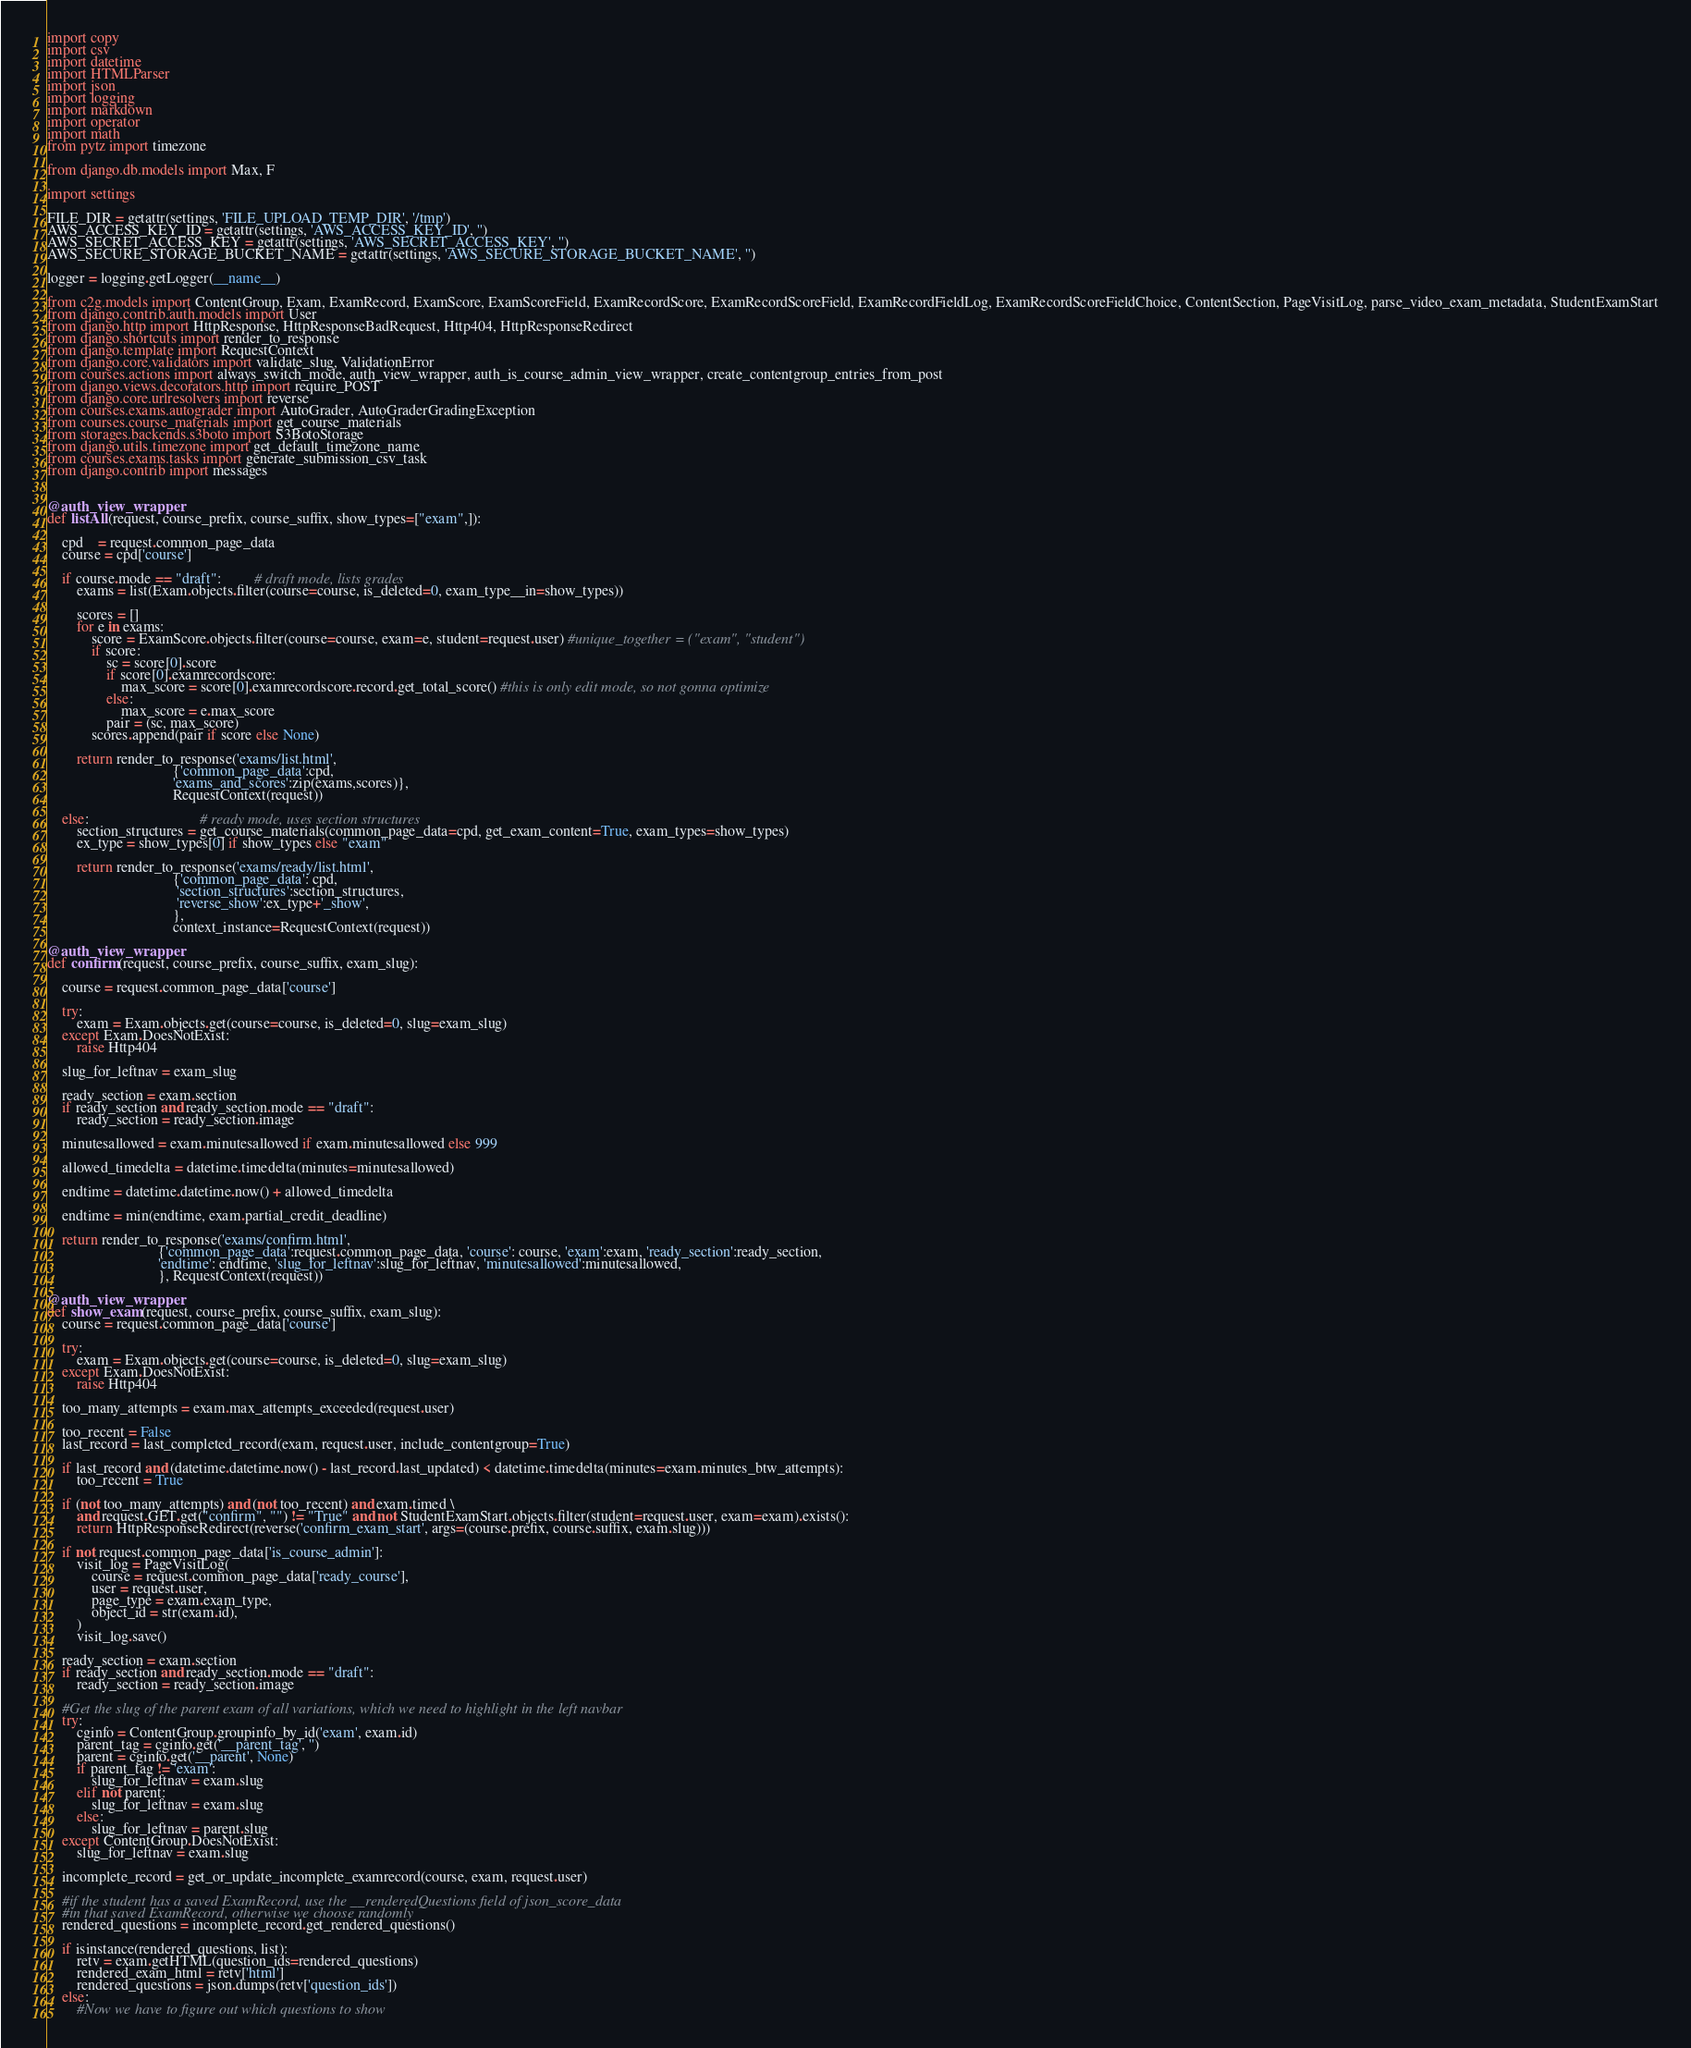<code> <loc_0><loc_0><loc_500><loc_500><_Python_>import copy
import csv
import datetime
import HTMLParser
import json
import logging
import markdown
import operator
import math
from pytz import timezone

from django.db.models import Max, F

import settings

FILE_DIR = getattr(settings, 'FILE_UPLOAD_TEMP_DIR', '/tmp')
AWS_ACCESS_KEY_ID = getattr(settings, 'AWS_ACCESS_KEY_ID', '')
AWS_SECRET_ACCESS_KEY = getattr(settings, 'AWS_SECRET_ACCESS_KEY', '')
AWS_SECURE_STORAGE_BUCKET_NAME = getattr(settings, 'AWS_SECURE_STORAGE_BUCKET_NAME', '')

logger = logging.getLogger(__name__)

from c2g.models import ContentGroup, Exam, ExamRecord, ExamScore, ExamScoreField, ExamRecordScore, ExamRecordScoreField, ExamRecordFieldLog, ExamRecordScoreFieldChoice, ContentSection, PageVisitLog, parse_video_exam_metadata, StudentExamStart
from django.contrib.auth.models import User
from django.http import HttpResponse, HttpResponseBadRequest, Http404, HttpResponseRedirect
from django.shortcuts import render_to_response
from django.template import RequestContext
from django.core.validators import validate_slug, ValidationError
from courses.actions import always_switch_mode, auth_view_wrapper, auth_is_course_admin_view_wrapper, create_contentgroup_entries_from_post
from django.views.decorators.http import require_POST
from django.core.urlresolvers import reverse
from courses.exams.autograder import AutoGrader, AutoGraderGradingException 
from courses.course_materials import get_course_materials
from storages.backends.s3boto import S3BotoStorage
from django.utils.timezone import get_default_timezone_name
from courses.exams.tasks import generate_submission_csv_task
from django.contrib import messages


@auth_view_wrapper
def listAll(request, course_prefix, course_suffix, show_types=["exam",]):
    
    cpd    = request.common_page_data
    course = cpd['course']

    if course.mode == "draft":         # draft mode, lists grades
        exams = list(Exam.objects.filter(course=course, is_deleted=0, exam_type__in=show_types))

        scores = []
        for e in exams:
            score = ExamScore.objects.filter(course=course, exam=e, student=request.user) #unique_together = ("exam", "student")
            if score:
                sc = score[0].score
                if score[0].examrecordscore:
                    max_score = score[0].examrecordscore.record.get_total_score() #this is only edit mode, so not gonna optimize
                else:
                    max_score = e.max_score
                pair = (sc, max_score)
            scores.append(pair if score else None)

        return render_to_response('exams/list.html',
                                  {'common_page_data':cpd,
                                  'exams_and_scores':zip(exams,scores)},
                                  RequestContext(request))

    else:                              # ready mode, uses section structures
        section_structures = get_course_materials(common_page_data=cpd, get_exam_content=True, exam_types=show_types)
        ex_type = show_types[0] if show_types else "exam" 
        
        return render_to_response('exams/ready/list.html', 
                                  {'common_page_data': cpd, 
                                   'section_structures':section_structures, 
                                   'reverse_show':ex_type+'_show', 
                                  }, 
                                  context_instance=RequestContext(request))

@auth_view_wrapper
def confirm(request, course_prefix, course_suffix, exam_slug):
    
    course = request.common_page_data['course']
        
    try:
        exam = Exam.objects.get(course=course, is_deleted=0, slug=exam_slug)
    except Exam.DoesNotExist:
        raise Http404

    slug_for_leftnav = exam_slug

    ready_section = exam.section
    if ready_section and ready_section.mode == "draft":
        ready_section = ready_section.image

    minutesallowed = exam.minutesallowed if exam.minutesallowed else 999

    allowed_timedelta = datetime.timedelta(minutes=minutesallowed)

    endtime = datetime.datetime.now() + allowed_timedelta
    
    endtime = min(endtime, exam.partial_credit_deadline)

    return render_to_response('exams/confirm.html',
                              {'common_page_data':request.common_page_data, 'course': course, 'exam':exam, 'ready_section':ready_section,
                              'endtime': endtime, 'slug_for_leftnav':slug_for_leftnav, 'minutesallowed':minutesallowed,
                              }, RequestContext(request))

@auth_view_wrapper
def show_exam(request, course_prefix, course_suffix, exam_slug):
    course = request.common_page_data['course']
    
    try:
        exam = Exam.objects.get(course=course, is_deleted=0, slug=exam_slug)
    except Exam.DoesNotExist:
        raise Http404

    too_many_attempts = exam.max_attempts_exceeded(request.user)

    too_recent = False
    last_record = last_completed_record(exam, request.user, include_contentgroup=True)

    if last_record and (datetime.datetime.now() - last_record.last_updated) < datetime.timedelta(minutes=exam.minutes_btw_attempts):
        too_recent = True

    if (not too_many_attempts) and (not too_recent) and exam.timed \
        and request.GET.get("confirm", "") != "True" and not StudentExamStart.objects.filter(student=request.user, exam=exam).exists():
        return HttpResponseRedirect(reverse('confirm_exam_start', args=(course.prefix, course.suffix, exam.slug)))

    if not request.common_page_data['is_course_admin']:
        visit_log = PageVisitLog(
            course = request.common_page_data['ready_course'],
            user = request.user,
            page_type = exam.exam_type,
            object_id = str(exam.id),
        )
        visit_log.save()

    ready_section = exam.section
    if ready_section and ready_section.mode == "draft":
        ready_section = ready_section.image

    #Get the slug of the parent exam of all variations, which we need to highlight in the left navbar
    try:
        cginfo = ContentGroup.groupinfo_by_id('exam', exam.id)
        parent_tag = cginfo.get('__parent_tag', '')
        parent = cginfo.get('__parent', None)
        if parent_tag != 'exam':
            slug_for_leftnav = exam.slug
        elif not parent:
            slug_for_leftnav = exam.slug
        else:
            slug_for_leftnav = parent.slug
    except ContentGroup.DoesNotExist:
        slug_for_leftnav = exam.slug

    incomplete_record = get_or_update_incomplete_examrecord(course, exam, request.user)

    #if the student has a saved ExamRecord, use the __renderedQuestions field of json_score_data
    #in that saved ExamRecord, otherwise we choose randomly
    rendered_questions = incomplete_record.get_rendered_questions()

    if isinstance(rendered_questions, list):
        retv = exam.getHTML(question_ids=rendered_questions)
        rendered_exam_html = retv['html']
        rendered_questions = json.dumps(retv['question_ids'])
    else:
        #Now we have to figure out which questions to show</code> 